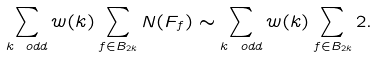<formula> <loc_0><loc_0><loc_500><loc_500>\sum _ { k \ o d d } w ( k ) \sum _ { f \in B _ { 2 k } } N ( F _ { f } ) \sim \sum _ { k \ o d d } w ( k ) \sum _ { f \in B _ { 2 k } } 2 .</formula> 